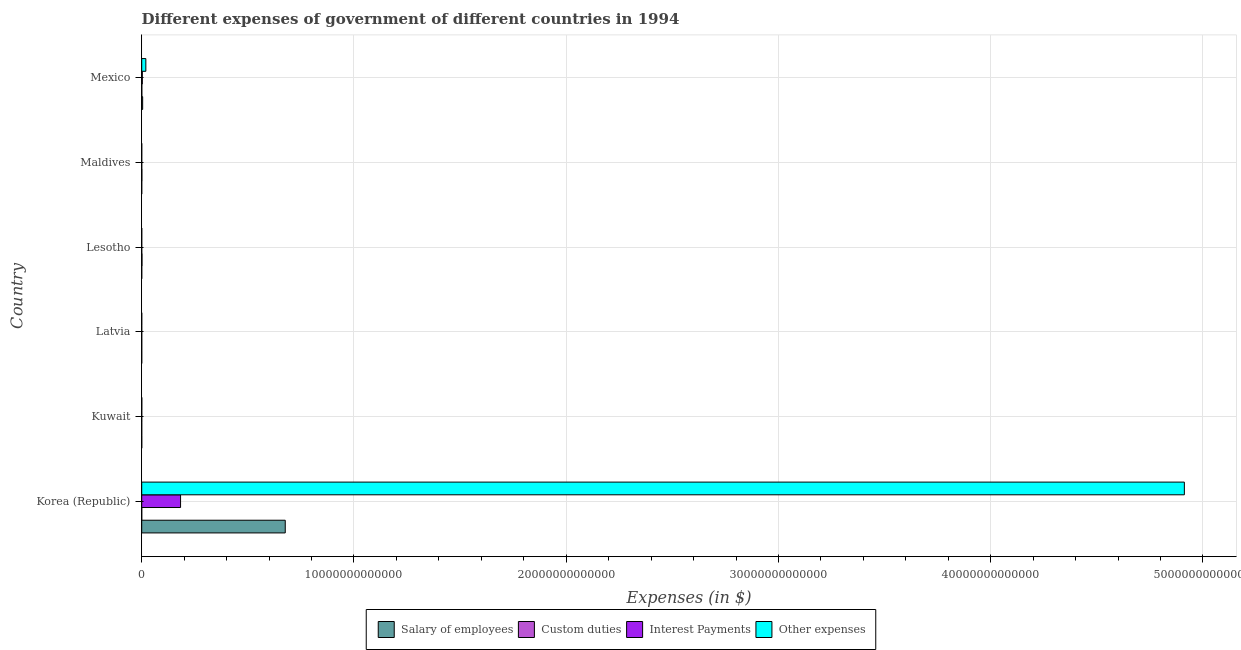How many different coloured bars are there?
Provide a short and direct response. 4. Are the number of bars per tick equal to the number of legend labels?
Provide a short and direct response. Yes. How many bars are there on the 6th tick from the bottom?
Your answer should be compact. 4. What is the label of the 3rd group of bars from the top?
Provide a succinct answer. Lesotho. In how many cases, is the number of bars for a given country not equal to the number of legend labels?
Keep it short and to the point. 0. What is the amount spent on interest payments in Mexico?
Your answer should be compact. 2.85e+1. Across all countries, what is the maximum amount spent on interest payments?
Offer a terse response. 1.83e+12. Across all countries, what is the minimum amount spent on salary of employees?
Ensure brevity in your answer.  9.94e+07. In which country was the amount spent on interest payments maximum?
Ensure brevity in your answer.  Korea (Republic). In which country was the amount spent on interest payments minimum?
Your response must be concise. Latvia. What is the total amount spent on custom duties in the graph?
Your answer should be very brief. 2.49e+1. What is the difference between the amount spent on other expenses in Korea (Republic) and that in Kuwait?
Make the answer very short. 4.91e+13. What is the difference between the amount spent on custom duties in Kuwait and the amount spent on interest payments in Korea (Republic)?
Make the answer very short. -1.83e+12. What is the average amount spent on other expenses per country?
Give a very brief answer. 8.22e+12. What is the difference between the amount spent on salary of employees and amount spent on custom duties in Latvia?
Make the answer very short. -2.41e+08. What is the ratio of the amount spent on salary of employees in Latvia to that in Mexico?
Your answer should be compact. 0. Is the amount spent on salary of employees in Korea (Republic) less than that in Lesotho?
Provide a short and direct response. No. Is the difference between the amount spent on custom duties in Kuwait and Maldives greater than the difference between the amount spent on other expenses in Kuwait and Maldives?
Your response must be concise. No. What is the difference between the highest and the second highest amount spent on other expenses?
Offer a very short reply. 4.89e+13. What is the difference between the highest and the lowest amount spent on other expenses?
Your answer should be compact. 4.91e+13. Is the sum of the amount spent on other expenses in Lesotho and Mexico greater than the maximum amount spent on interest payments across all countries?
Offer a terse response. No. Is it the case that in every country, the sum of the amount spent on other expenses and amount spent on interest payments is greater than the sum of amount spent on salary of employees and amount spent on custom duties?
Offer a terse response. No. What does the 3rd bar from the top in Maldives represents?
Keep it short and to the point. Custom duties. What does the 1st bar from the bottom in Lesotho represents?
Your response must be concise. Salary of employees. How many bars are there?
Make the answer very short. 24. Are all the bars in the graph horizontal?
Give a very brief answer. Yes. How many countries are there in the graph?
Provide a succinct answer. 6. What is the difference between two consecutive major ticks on the X-axis?
Your answer should be very brief. 1.00e+13. Does the graph contain any zero values?
Ensure brevity in your answer.  No. Where does the legend appear in the graph?
Offer a terse response. Bottom center. What is the title of the graph?
Provide a short and direct response. Different expenses of government of different countries in 1994. Does "Terrestrial protected areas" appear as one of the legend labels in the graph?
Offer a very short reply. No. What is the label or title of the X-axis?
Give a very brief answer. Expenses (in $). What is the Expenses (in $) in Salary of employees in Korea (Republic)?
Your answer should be very brief. 6.76e+12. What is the Expenses (in $) of Custom duties in Korea (Republic)?
Provide a succinct answer. 6.80e+07. What is the Expenses (in $) in Interest Payments in Korea (Republic)?
Provide a succinct answer. 1.83e+12. What is the Expenses (in $) of Other expenses in Korea (Republic)?
Ensure brevity in your answer.  4.91e+13. What is the Expenses (in $) of Salary of employees in Kuwait?
Offer a terse response. 1.11e+09. What is the Expenses (in $) of Custom duties in Kuwait?
Offer a terse response. 2.34e+07. What is the Expenses (in $) of Interest Payments in Kuwait?
Provide a succinct answer. 3.96e+08. What is the Expenses (in $) in Other expenses in Kuwait?
Offer a terse response. 3.63e+09. What is the Expenses (in $) in Salary of employees in Latvia?
Offer a terse response. 9.94e+07. What is the Expenses (in $) in Custom duties in Latvia?
Your response must be concise. 3.40e+08. What is the Expenses (in $) in Interest Payments in Latvia?
Make the answer very short. 8.72e+06. What is the Expenses (in $) of Other expenses in Latvia?
Offer a very short reply. 5.43e+08. What is the Expenses (in $) in Salary of employees in Lesotho?
Provide a succinct answer. 4.60e+08. What is the Expenses (in $) of Custom duties in Lesotho?
Provide a succinct answer. 1.27e+1. What is the Expenses (in $) of Interest Payments in Lesotho?
Keep it short and to the point. 4.94e+07. What is the Expenses (in $) in Other expenses in Lesotho?
Provide a short and direct response. 1.05e+09. What is the Expenses (in $) of Salary of employees in Maldives?
Make the answer very short. 1.85e+08. What is the Expenses (in $) of Custom duties in Maldives?
Your answer should be compact. 7.54e+09. What is the Expenses (in $) of Interest Payments in Maldives?
Offer a terse response. 5.61e+07. What is the Expenses (in $) of Other expenses in Maldives?
Provide a succinct answer. 6.92e+08. What is the Expenses (in $) of Salary of employees in Mexico?
Provide a succinct answer. 4.41e+1. What is the Expenses (in $) of Custom duties in Mexico?
Provide a succinct answer. 4.22e+09. What is the Expenses (in $) in Interest Payments in Mexico?
Make the answer very short. 2.85e+1. What is the Expenses (in $) of Other expenses in Mexico?
Your answer should be compact. 1.94e+11. Across all countries, what is the maximum Expenses (in $) of Salary of employees?
Give a very brief answer. 6.76e+12. Across all countries, what is the maximum Expenses (in $) of Custom duties?
Make the answer very short. 1.27e+1. Across all countries, what is the maximum Expenses (in $) of Interest Payments?
Offer a very short reply. 1.83e+12. Across all countries, what is the maximum Expenses (in $) in Other expenses?
Provide a short and direct response. 4.91e+13. Across all countries, what is the minimum Expenses (in $) in Salary of employees?
Give a very brief answer. 9.94e+07. Across all countries, what is the minimum Expenses (in $) of Custom duties?
Offer a very short reply. 2.34e+07. Across all countries, what is the minimum Expenses (in $) of Interest Payments?
Your response must be concise. 8.72e+06. Across all countries, what is the minimum Expenses (in $) of Other expenses?
Ensure brevity in your answer.  5.43e+08. What is the total Expenses (in $) of Salary of employees in the graph?
Ensure brevity in your answer.  6.81e+12. What is the total Expenses (in $) of Custom duties in the graph?
Your answer should be compact. 2.49e+1. What is the total Expenses (in $) in Interest Payments in the graph?
Provide a short and direct response. 1.86e+12. What is the total Expenses (in $) in Other expenses in the graph?
Provide a short and direct response. 4.93e+13. What is the difference between the Expenses (in $) in Salary of employees in Korea (Republic) and that in Kuwait?
Ensure brevity in your answer.  6.76e+12. What is the difference between the Expenses (in $) of Custom duties in Korea (Republic) and that in Kuwait?
Make the answer very short. 4.46e+07. What is the difference between the Expenses (in $) of Interest Payments in Korea (Republic) and that in Kuwait?
Your response must be concise. 1.83e+12. What is the difference between the Expenses (in $) in Other expenses in Korea (Republic) and that in Kuwait?
Provide a short and direct response. 4.91e+13. What is the difference between the Expenses (in $) of Salary of employees in Korea (Republic) and that in Latvia?
Provide a succinct answer. 6.76e+12. What is the difference between the Expenses (in $) of Custom duties in Korea (Republic) and that in Latvia?
Your answer should be very brief. -2.72e+08. What is the difference between the Expenses (in $) of Interest Payments in Korea (Republic) and that in Latvia?
Your answer should be compact. 1.83e+12. What is the difference between the Expenses (in $) of Other expenses in Korea (Republic) and that in Latvia?
Ensure brevity in your answer.  4.91e+13. What is the difference between the Expenses (in $) in Salary of employees in Korea (Republic) and that in Lesotho?
Your answer should be very brief. 6.76e+12. What is the difference between the Expenses (in $) in Custom duties in Korea (Republic) and that in Lesotho?
Give a very brief answer. -1.26e+1. What is the difference between the Expenses (in $) of Interest Payments in Korea (Republic) and that in Lesotho?
Give a very brief answer. 1.83e+12. What is the difference between the Expenses (in $) of Other expenses in Korea (Republic) and that in Lesotho?
Make the answer very short. 4.91e+13. What is the difference between the Expenses (in $) in Salary of employees in Korea (Republic) and that in Maldives?
Offer a terse response. 6.76e+12. What is the difference between the Expenses (in $) in Custom duties in Korea (Republic) and that in Maldives?
Your answer should be compact. -7.47e+09. What is the difference between the Expenses (in $) in Interest Payments in Korea (Republic) and that in Maldives?
Your answer should be compact. 1.83e+12. What is the difference between the Expenses (in $) in Other expenses in Korea (Republic) and that in Maldives?
Give a very brief answer. 4.91e+13. What is the difference between the Expenses (in $) in Salary of employees in Korea (Republic) and that in Mexico?
Your answer should be compact. 6.72e+12. What is the difference between the Expenses (in $) in Custom duties in Korea (Republic) and that in Mexico?
Your response must be concise. -4.16e+09. What is the difference between the Expenses (in $) in Interest Payments in Korea (Republic) and that in Mexico?
Give a very brief answer. 1.80e+12. What is the difference between the Expenses (in $) in Other expenses in Korea (Republic) and that in Mexico?
Your response must be concise. 4.89e+13. What is the difference between the Expenses (in $) in Salary of employees in Kuwait and that in Latvia?
Make the answer very short. 1.01e+09. What is the difference between the Expenses (in $) in Custom duties in Kuwait and that in Latvia?
Offer a terse response. -3.17e+08. What is the difference between the Expenses (in $) in Interest Payments in Kuwait and that in Latvia?
Your response must be concise. 3.87e+08. What is the difference between the Expenses (in $) in Other expenses in Kuwait and that in Latvia?
Keep it short and to the point. 3.09e+09. What is the difference between the Expenses (in $) of Salary of employees in Kuwait and that in Lesotho?
Your response must be concise. 6.48e+08. What is the difference between the Expenses (in $) of Custom duties in Kuwait and that in Lesotho?
Ensure brevity in your answer.  -1.27e+1. What is the difference between the Expenses (in $) of Interest Payments in Kuwait and that in Lesotho?
Your answer should be very brief. 3.47e+08. What is the difference between the Expenses (in $) of Other expenses in Kuwait and that in Lesotho?
Keep it short and to the point. 2.58e+09. What is the difference between the Expenses (in $) of Salary of employees in Kuwait and that in Maldives?
Ensure brevity in your answer.  9.23e+08. What is the difference between the Expenses (in $) in Custom duties in Kuwait and that in Maldives?
Keep it short and to the point. -7.52e+09. What is the difference between the Expenses (in $) of Interest Payments in Kuwait and that in Maldives?
Your response must be concise. 3.40e+08. What is the difference between the Expenses (in $) of Other expenses in Kuwait and that in Maldives?
Your answer should be compact. 2.94e+09. What is the difference between the Expenses (in $) in Salary of employees in Kuwait and that in Mexico?
Provide a succinct answer. -4.30e+1. What is the difference between the Expenses (in $) of Custom duties in Kuwait and that in Mexico?
Offer a very short reply. -4.20e+09. What is the difference between the Expenses (in $) of Interest Payments in Kuwait and that in Mexico?
Your response must be concise. -2.81e+1. What is the difference between the Expenses (in $) of Other expenses in Kuwait and that in Mexico?
Your answer should be very brief. -1.91e+11. What is the difference between the Expenses (in $) in Salary of employees in Latvia and that in Lesotho?
Ensure brevity in your answer.  -3.60e+08. What is the difference between the Expenses (in $) in Custom duties in Latvia and that in Lesotho?
Your response must be concise. -1.24e+1. What is the difference between the Expenses (in $) of Interest Payments in Latvia and that in Lesotho?
Your response must be concise. -4.07e+07. What is the difference between the Expenses (in $) of Other expenses in Latvia and that in Lesotho?
Offer a very short reply. -5.08e+08. What is the difference between the Expenses (in $) of Salary of employees in Latvia and that in Maldives?
Ensure brevity in your answer.  -8.55e+07. What is the difference between the Expenses (in $) in Custom duties in Latvia and that in Maldives?
Offer a terse response. -7.20e+09. What is the difference between the Expenses (in $) in Interest Payments in Latvia and that in Maldives?
Your answer should be very brief. -4.74e+07. What is the difference between the Expenses (in $) in Other expenses in Latvia and that in Maldives?
Offer a very short reply. -1.48e+08. What is the difference between the Expenses (in $) in Salary of employees in Latvia and that in Mexico?
Keep it short and to the point. -4.40e+1. What is the difference between the Expenses (in $) in Custom duties in Latvia and that in Mexico?
Provide a short and direct response. -3.88e+09. What is the difference between the Expenses (in $) in Interest Payments in Latvia and that in Mexico?
Make the answer very short. -2.85e+1. What is the difference between the Expenses (in $) in Other expenses in Latvia and that in Mexico?
Ensure brevity in your answer.  -1.94e+11. What is the difference between the Expenses (in $) in Salary of employees in Lesotho and that in Maldives?
Make the answer very short. 2.75e+08. What is the difference between the Expenses (in $) in Custom duties in Lesotho and that in Maldives?
Give a very brief answer. 5.17e+09. What is the difference between the Expenses (in $) of Interest Payments in Lesotho and that in Maldives?
Provide a succinct answer. -6.70e+06. What is the difference between the Expenses (in $) of Other expenses in Lesotho and that in Maldives?
Your answer should be compact. 3.59e+08. What is the difference between the Expenses (in $) in Salary of employees in Lesotho and that in Mexico?
Ensure brevity in your answer.  -4.37e+1. What is the difference between the Expenses (in $) in Custom duties in Lesotho and that in Mexico?
Offer a very short reply. 8.48e+09. What is the difference between the Expenses (in $) in Interest Payments in Lesotho and that in Mexico?
Keep it short and to the point. -2.84e+1. What is the difference between the Expenses (in $) of Other expenses in Lesotho and that in Mexico?
Your response must be concise. -1.93e+11. What is the difference between the Expenses (in $) in Salary of employees in Maldives and that in Mexico?
Give a very brief answer. -4.39e+1. What is the difference between the Expenses (in $) of Custom duties in Maldives and that in Mexico?
Your answer should be very brief. 3.32e+09. What is the difference between the Expenses (in $) in Interest Payments in Maldives and that in Mexico?
Provide a short and direct response. -2.84e+1. What is the difference between the Expenses (in $) of Other expenses in Maldives and that in Mexico?
Your response must be concise. -1.94e+11. What is the difference between the Expenses (in $) of Salary of employees in Korea (Republic) and the Expenses (in $) of Custom duties in Kuwait?
Provide a succinct answer. 6.76e+12. What is the difference between the Expenses (in $) in Salary of employees in Korea (Republic) and the Expenses (in $) in Interest Payments in Kuwait?
Offer a very short reply. 6.76e+12. What is the difference between the Expenses (in $) of Salary of employees in Korea (Republic) and the Expenses (in $) of Other expenses in Kuwait?
Ensure brevity in your answer.  6.76e+12. What is the difference between the Expenses (in $) of Custom duties in Korea (Republic) and the Expenses (in $) of Interest Payments in Kuwait?
Your response must be concise. -3.28e+08. What is the difference between the Expenses (in $) of Custom duties in Korea (Republic) and the Expenses (in $) of Other expenses in Kuwait?
Provide a succinct answer. -3.57e+09. What is the difference between the Expenses (in $) in Interest Payments in Korea (Republic) and the Expenses (in $) in Other expenses in Kuwait?
Keep it short and to the point. 1.83e+12. What is the difference between the Expenses (in $) in Salary of employees in Korea (Republic) and the Expenses (in $) in Custom duties in Latvia?
Give a very brief answer. 6.76e+12. What is the difference between the Expenses (in $) of Salary of employees in Korea (Republic) and the Expenses (in $) of Interest Payments in Latvia?
Give a very brief answer. 6.76e+12. What is the difference between the Expenses (in $) of Salary of employees in Korea (Republic) and the Expenses (in $) of Other expenses in Latvia?
Provide a succinct answer. 6.76e+12. What is the difference between the Expenses (in $) of Custom duties in Korea (Republic) and the Expenses (in $) of Interest Payments in Latvia?
Offer a very short reply. 5.93e+07. What is the difference between the Expenses (in $) of Custom duties in Korea (Republic) and the Expenses (in $) of Other expenses in Latvia?
Keep it short and to the point. -4.75e+08. What is the difference between the Expenses (in $) in Interest Payments in Korea (Republic) and the Expenses (in $) in Other expenses in Latvia?
Your answer should be compact. 1.83e+12. What is the difference between the Expenses (in $) in Salary of employees in Korea (Republic) and the Expenses (in $) in Custom duties in Lesotho?
Provide a succinct answer. 6.75e+12. What is the difference between the Expenses (in $) of Salary of employees in Korea (Republic) and the Expenses (in $) of Interest Payments in Lesotho?
Offer a terse response. 6.76e+12. What is the difference between the Expenses (in $) in Salary of employees in Korea (Republic) and the Expenses (in $) in Other expenses in Lesotho?
Give a very brief answer. 6.76e+12. What is the difference between the Expenses (in $) in Custom duties in Korea (Republic) and the Expenses (in $) in Interest Payments in Lesotho?
Make the answer very short. 1.86e+07. What is the difference between the Expenses (in $) of Custom duties in Korea (Republic) and the Expenses (in $) of Other expenses in Lesotho?
Provide a succinct answer. -9.83e+08. What is the difference between the Expenses (in $) in Interest Payments in Korea (Republic) and the Expenses (in $) in Other expenses in Lesotho?
Ensure brevity in your answer.  1.83e+12. What is the difference between the Expenses (in $) of Salary of employees in Korea (Republic) and the Expenses (in $) of Custom duties in Maldives?
Provide a short and direct response. 6.75e+12. What is the difference between the Expenses (in $) of Salary of employees in Korea (Republic) and the Expenses (in $) of Interest Payments in Maldives?
Provide a succinct answer. 6.76e+12. What is the difference between the Expenses (in $) in Salary of employees in Korea (Republic) and the Expenses (in $) in Other expenses in Maldives?
Make the answer very short. 6.76e+12. What is the difference between the Expenses (in $) of Custom duties in Korea (Republic) and the Expenses (in $) of Interest Payments in Maldives?
Give a very brief answer. 1.19e+07. What is the difference between the Expenses (in $) in Custom duties in Korea (Republic) and the Expenses (in $) in Other expenses in Maldives?
Give a very brief answer. -6.24e+08. What is the difference between the Expenses (in $) of Interest Payments in Korea (Republic) and the Expenses (in $) of Other expenses in Maldives?
Offer a very short reply. 1.83e+12. What is the difference between the Expenses (in $) of Salary of employees in Korea (Republic) and the Expenses (in $) of Custom duties in Mexico?
Make the answer very short. 6.76e+12. What is the difference between the Expenses (in $) of Salary of employees in Korea (Republic) and the Expenses (in $) of Interest Payments in Mexico?
Offer a very short reply. 6.73e+12. What is the difference between the Expenses (in $) of Salary of employees in Korea (Republic) and the Expenses (in $) of Other expenses in Mexico?
Offer a very short reply. 6.57e+12. What is the difference between the Expenses (in $) in Custom duties in Korea (Republic) and the Expenses (in $) in Interest Payments in Mexico?
Give a very brief answer. -2.84e+1. What is the difference between the Expenses (in $) of Custom duties in Korea (Republic) and the Expenses (in $) of Other expenses in Mexico?
Offer a terse response. -1.94e+11. What is the difference between the Expenses (in $) in Interest Payments in Korea (Republic) and the Expenses (in $) in Other expenses in Mexico?
Provide a short and direct response. 1.64e+12. What is the difference between the Expenses (in $) in Salary of employees in Kuwait and the Expenses (in $) in Custom duties in Latvia?
Ensure brevity in your answer.  7.68e+08. What is the difference between the Expenses (in $) of Salary of employees in Kuwait and the Expenses (in $) of Interest Payments in Latvia?
Give a very brief answer. 1.10e+09. What is the difference between the Expenses (in $) in Salary of employees in Kuwait and the Expenses (in $) in Other expenses in Latvia?
Your response must be concise. 5.65e+08. What is the difference between the Expenses (in $) in Custom duties in Kuwait and the Expenses (in $) in Interest Payments in Latvia?
Provide a short and direct response. 1.47e+07. What is the difference between the Expenses (in $) in Custom duties in Kuwait and the Expenses (in $) in Other expenses in Latvia?
Ensure brevity in your answer.  -5.20e+08. What is the difference between the Expenses (in $) in Interest Payments in Kuwait and the Expenses (in $) in Other expenses in Latvia?
Offer a terse response. -1.47e+08. What is the difference between the Expenses (in $) of Salary of employees in Kuwait and the Expenses (in $) of Custom duties in Lesotho?
Your answer should be very brief. -1.16e+1. What is the difference between the Expenses (in $) in Salary of employees in Kuwait and the Expenses (in $) in Interest Payments in Lesotho?
Your answer should be compact. 1.06e+09. What is the difference between the Expenses (in $) in Salary of employees in Kuwait and the Expenses (in $) in Other expenses in Lesotho?
Give a very brief answer. 5.67e+07. What is the difference between the Expenses (in $) of Custom duties in Kuwait and the Expenses (in $) of Interest Payments in Lesotho?
Ensure brevity in your answer.  -2.60e+07. What is the difference between the Expenses (in $) in Custom duties in Kuwait and the Expenses (in $) in Other expenses in Lesotho?
Provide a succinct answer. -1.03e+09. What is the difference between the Expenses (in $) of Interest Payments in Kuwait and the Expenses (in $) of Other expenses in Lesotho?
Give a very brief answer. -6.55e+08. What is the difference between the Expenses (in $) in Salary of employees in Kuwait and the Expenses (in $) in Custom duties in Maldives?
Your answer should be very brief. -6.43e+09. What is the difference between the Expenses (in $) of Salary of employees in Kuwait and the Expenses (in $) of Interest Payments in Maldives?
Ensure brevity in your answer.  1.05e+09. What is the difference between the Expenses (in $) in Salary of employees in Kuwait and the Expenses (in $) in Other expenses in Maldives?
Ensure brevity in your answer.  4.16e+08. What is the difference between the Expenses (in $) in Custom duties in Kuwait and the Expenses (in $) in Interest Payments in Maldives?
Your answer should be compact. -3.27e+07. What is the difference between the Expenses (in $) in Custom duties in Kuwait and the Expenses (in $) in Other expenses in Maldives?
Offer a very short reply. -6.68e+08. What is the difference between the Expenses (in $) of Interest Payments in Kuwait and the Expenses (in $) of Other expenses in Maldives?
Your answer should be compact. -2.96e+08. What is the difference between the Expenses (in $) in Salary of employees in Kuwait and the Expenses (in $) in Custom duties in Mexico?
Your answer should be very brief. -3.12e+09. What is the difference between the Expenses (in $) in Salary of employees in Kuwait and the Expenses (in $) in Interest Payments in Mexico?
Make the answer very short. -2.74e+1. What is the difference between the Expenses (in $) in Salary of employees in Kuwait and the Expenses (in $) in Other expenses in Mexico?
Provide a succinct answer. -1.93e+11. What is the difference between the Expenses (in $) of Custom duties in Kuwait and the Expenses (in $) of Interest Payments in Mexico?
Ensure brevity in your answer.  -2.85e+1. What is the difference between the Expenses (in $) in Custom duties in Kuwait and the Expenses (in $) in Other expenses in Mexico?
Ensure brevity in your answer.  -1.94e+11. What is the difference between the Expenses (in $) of Interest Payments in Kuwait and the Expenses (in $) of Other expenses in Mexico?
Provide a short and direct response. -1.94e+11. What is the difference between the Expenses (in $) in Salary of employees in Latvia and the Expenses (in $) in Custom duties in Lesotho?
Make the answer very short. -1.26e+1. What is the difference between the Expenses (in $) of Salary of employees in Latvia and the Expenses (in $) of Interest Payments in Lesotho?
Make the answer very short. 5.00e+07. What is the difference between the Expenses (in $) of Salary of employees in Latvia and the Expenses (in $) of Other expenses in Lesotho?
Offer a terse response. -9.52e+08. What is the difference between the Expenses (in $) in Custom duties in Latvia and the Expenses (in $) in Interest Payments in Lesotho?
Your response must be concise. 2.91e+08. What is the difference between the Expenses (in $) of Custom duties in Latvia and the Expenses (in $) of Other expenses in Lesotho?
Keep it short and to the point. -7.11e+08. What is the difference between the Expenses (in $) in Interest Payments in Latvia and the Expenses (in $) in Other expenses in Lesotho?
Ensure brevity in your answer.  -1.04e+09. What is the difference between the Expenses (in $) in Salary of employees in Latvia and the Expenses (in $) in Custom duties in Maldives?
Your answer should be very brief. -7.44e+09. What is the difference between the Expenses (in $) of Salary of employees in Latvia and the Expenses (in $) of Interest Payments in Maldives?
Offer a terse response. 4.33e+07. What is the difference between the Expenses (in $) in Salary of employees in Latvia and the Expenses (in $) in Other expenses in Maldives?
Your response must be concise. -5.92e+08. What is the difference between the Expenses (in $) in Custom duties in Latvia and the Expenses (in $) in Interest Payments in Maldives?
Give a very brief answer. 2.84e+08. What is the difference between the Expenses (in $) in Custom duties in Latvia and the Expenses (in $) in Other expenses in Maldives?
Your answer should be very brief. -3.52e+08. What is the difference between the Expenses (in $) of Interest Payments in Latvia and the Expenses (in $) of Other expenses in Maldives?
Your response must be concise. -6.83e+08. What is the difference between the Expenses (in $) of Salary of employees in Latvia and the Expenses (in $) of Custom duties in Mexico?
Provide a succinct answer. -4.13e+09. What is the difference between the Expenses (in $) in Salary of employees in Latvia and the Expenses (in $) in Interest Payments in Mexico?
Provide a short and direct response. -2.84e+1. What is the difference between the Expenses (in $) of Salary of employees in Latvia and the Expenses (in $) of Other expenses in Mexico?
Keep it short and to the point. -1.94e+11. What is the difference between the Expenses (in $) in Custom duties in Latvia and the Expenses (in $) in Interest Payments in Mexico?
Make the answer very short. -2.81e+1. What is the difference between the Expenses (in $) of Custom duties in Latvia and the Expenses (in $) of Other expenses in Mexico?
Make the answer very short. -1.94e+11. What is the difference between the Expenses (in $) in Interest Payments in Latvia and the Expenses (in $) in Other expenses in Mexico?
Offer a terse response. -1.94e+11. What is the difference between the Expenses (in $) in Salary of employees in Lesotho and the Expenses (in $) in Custom duties in Maldives?
Give a very brief answer. -7.08e+09. What is the difference between the Expenses (in $) in Salary of employees in Lesotho and the Expenses (in $) in Interest Payments in Maldives?
Your answer should be compact. 4.04e+08. What is the difference between the Expenses (in $) of Salary of employees in Lesotho and the Expenses (in $) of Other expenses in Maldives?
Your answer should be very brief. -2.32e+08. What is the difference between the Expenses (in $) in Custom duties in Lesotho and the Expenses (in $) in Interest Payments in Maldives?
Provide a short and direct response. 1.27e+1. What is the difference between the Expenses (in $) in Custom duties in Lesotho and the Expenses (in $) in Other expenses in Maldives?
Provide a succinct answer. 1.20e+1. What is the difference between the Expenses (in $) in Interest Payments in Lesotho and the Expenses (in $) in Other expenses in Maldives?
Your response must be concise. -6.42e+08. What is the difference between the Expenses (in $) in Salary of employees in Lesotho and the Expenses (in $) in Custom duties in Mexico?
Offer a terse response. -3.77e+09. What is the difference between the Expenses (in $) of Salary of employees in Lesotho and the Expenses (in $) of Interest Payments in Mexico?
Ensure brevity in your answer.  -2.80e+1. What is the difference between the Expenses (in $) of Salary of employees in Lesotho and the Expenses (in $) of Other expenses in Mexico?
Your response must be concise. -1.94e+11. What is the difference between the Expenses (in $) of Custom duties in Lesotho and the Expenses (in $) of Interest Payments in Mexico?
Keep it short and to the point. -1.58e+1. What is the difference between the Expenses (in $) in Custom duties in Lesotho and the Expenses (in $) in Other expenses in Mexico?
Your answer should be compact. -1.82e+11. What is the difference between the Expenses (in $) of Interest Payments in Lesotho and the Expenses (in $) of Other expenses in Mexico?
Your response must be concise. -1.94e+11. What is the difference between the Expenses (in $) in Salary of employees in Maldives and the Expenses (in $) in Custom duties in Mexico?
Your response must be concise. -4.04e+09. What is the difference between the Expenses (in $) in Salary of employees in Maldives and the Expenses (in $) in Interest Payments in Mexico?
Your answer should be very brief. -2.83e+1. What is the difference between the Expenses (in $) in Salary of employees in Maldives and the Expenses (in $) in Other expenses in Mexico?
Ensure brevity in your answer.  -1.94e+11. What is the difference between the Expenses (in $) of Custom duties in Maldives and the Expenses (in $) of Interest Payments in Mexico?
Offer a terse response. -2.09e+1. What is the difference between the Expenses (in $) of Custom duties in Maldives and the Expenses (in $) of Other expenses in Mexico?
Your answer should be compact. -1.87e+11. What is the difference between the Expenses (in $) of Interest Payments in Maldives and the Expenses (in $) of Other expenses in Mexico?
Provide a short and direct response. -1.94e+11. What is the average Expenses (in $) of Salary of employees per country?
Make the answer very short. 1.13e+12. What is the average Expenses (in $) of Custom duties per country?
Give a very brief answer. 4.15e+09. What is the average Expenses (in $) in Interest Payments per country?
Make the answer very short. 3.10e+11. What is the average Expenses (in $) in Other expenses per country?
Offer a very short reply. 8.22e+12. What is the difference between the Expenses (in $) in Salary of employees and Expenses (in $) in Custom duties in Korea (Republic)?
Make the answer very short. 6.76e+12. What is the difference between the Expenses (in $) in Salary of employees and Expenses (in $) in Interest Payments in Korea (Republic)?
Keep it short and to the point. 4.93e+12. What is the difference between the Expenses (in $) in Salary of employees and Expenses (in $) in Other expenses in Korea (Republic)?
Provide a succinct answer. -4.24e+13. What is the difference between the Expenses (in $) of Custom duties and Expenses (in $) of Interest Payments in Korea (Republic)?
Give a very brief answer. -1.83e+12. What is the difference between the Expenses (in $) in Custom duties and Expenses (in $) in Other expenses in Korea (Republic)?
Your response must be concise. -4.91e+13. What is the difference between the Expenses (in $) of Interest Payments and Expenses (in $) of Other expenses in Korea (Republic)?
Provide a succinct answer. -4.73e+13. What is the difference between the Expenses (in $) of Salary of employees and Expenses (in $) of Custom duties in Kuwait?
Make the answer very short. 1.08e+09. What is the difference between the Expenses (in $) of Salary of employees and Expenses (in $) of Interest Payments in Kuwait?
Ensure brevity in your answer.  7.12e+08. What is the difference between the Expenses (in $) in Salary of employees and Expenses (in $) in Other expenses in Kuwait?
Provide a succinct answer. -2.53e+09. What is the difference between the Expenses (in $) in Custom duties and Expenses (in $) in Interest Payments in Kuwait?
Provide a succinct answer. -3.73e+08. What is the difference between the Expenses (in $) of Custom duties and Expenses (in $) of Other expenses in Kuwait?
Your answer should be very brief. -3.61e+09. What is the difference between the Expenses (in $) in Interest Payments and Expenses (in $) in Other expenses in Kuwait?
Offer a terse response. -3.24e+09. What is the difference between the Expenses (in $) in Salary of employees and Expenses (in $) in Custom duties in Latvia?
Keep it short and to the point. -2.41e+08. What is the difference between the Expenses (in $) in Salary of employees and Expenses (in $) in Interest Payments in Latvia?
Offer a very short reply. 9.07e+07. What is the difference between the Expenses (in $) in Salary of employees and Expenses (in $) in Other expenses in Latvia?
Ensure brevity in your answer.  -4.44e+08. What is the difference between the Expenses (in $) in Custom duties and Expenses (in $) in Interest Payments in Latvia?
Your answer should be very brief. 3.31e+08. What is the difference between the Expenses (in $) in Custom duties and Expenses (in $) in Other expenses in Latvia?
Ensure brevity in your answer.  -2.03e+08. What is the difference between the Expenses (in $) of Interest Payments and Expenses (in $) of Other expenses in Latvia?
Your answer should be compact. -5.35e+08. What is the difference between the Expenses (in $) in Salary of employees and Expenses (in $) in Custom duties in Lesotho?
Keep it short and to the point. -1.22e+1. What is the difference between the Expenses (in $) in Salary of employees and Expenses (in $) in Interest Payments in Lesotho?
Give a very brief answer. 4.10e+08. What is the difference between the Expenses (in $) of Salary of employees and Expenses (in $) of Other expenses in Lesotho?
Provide a short and direct response. -5.92e+08. What is the difference between the Expenses (in $) of Custom duties and Expenses (in $) of Interest Payments in Lesotho?
Ensure brevity in your answer.  1.27e+1. What is the difference between the Expenses (in $) of Custom duties and Expenses (in $) of Other expenses in Lesotho?
Your answer should be compact. 1.17e+1. What is the difference between the Expenses (in $) of Interest Payments and Expenses (in $) of Other expenses in Lesotho?
Offer a terse response. -1.00e+09. What is the difference between the Expenses (in $) in Salary of employees and Expenses (in $) in Custom duties in Maldives?
Offer a very short reply. -7.36e+09. What is the difference between the Expenses (in $) of Salary of employees and Expenses (in $) of Interest Payments in Maldives?
Provide a short and direct response. 1.29e+08. What is the difference between the Expenses (in $) in Salary of employees and Expenses (in $) in Other expenses in Maldives?
Ensure brevity in your answer.  -5.07e+08. What is the difference between the Expenses (in $) of Custom duties and Expenses (in $) of Interest Payments in Maldives?
Provide a succinct answer. 7.48e+09. What is the difference between the Expenses (in $) of Custom duties and Expenses (in $) of Other expenses in Maldives?
Give a very brief answer. 6.85e+09. What is the difference between the Expenses (in $) in Interest Payments and Expenses (in $) in Other expenses in Maldives?
Keep it short and to the point. -6.36e+08. What is the difference between the Expenses (in $) of Salary of employees and Expenses (in $) of Custom duties in Mexico?
Your answer should be very brief. 3.99e+1. What is the difference between the Expenses (in $) in Salary of employees and Expenses (in $) in Interest Payments in Mexico?
Give a very brief answer. 1.56e+1. What is the difference between the Expenses (in $) of Salary of employees and Expenses (in $) of Other expenses in Mexico?
Keep it short and to the point. -1.50e+11. What is the difference between the Expenses (in $) of Custom duties and Expenses (in $) of Interest Payments in Mexico?
Give a very brief answer. -2.43e+1. What is the difference between the Expenses (in $) of Custom duties and Expenses (in $) of Other expenses in Mexico?
Provide a short and direct response. -1.90e+11. What is the difference between the Expenses (in $) in Interest Payments and Expenses (in $) in Other expenses in Mexico?
Give a very brief answer. -1.66e+11. What is the ratio of the Expenses (in $) of Salary of employees in Korea (Republic) to that in Kuwait?
Your answer should be compact. 6102.89. What is the ratio of the Expenses (in $) in Custom duties in Korea (Republic) to that in Kuwait?
Provide a succinct answer. 2.9. What is the ratio of the Expenses (in $) in Interest Payments in Korea (Republic) to that in Kuwait?
Your answer should be very brief. 4621.21. What is the ratio of the Expenses (in $) in Other expenses in Korea (Republic) to that in Kuwait?
Provide a short and direct response. 1.35e+04. What is the ratio of the Expenses (in $) in Salary of employees in Korea (Republic) to that in Latvia?
Provide a succinct answer. 6.80e+04. What is the ratio of the Expenses (in $) in Custom duties in Korea (Republic) to that in Latvia?
Offer a terse response. 0.2. What is the ratio of the Expenses (in $) of Interest Payments in Korea (Republic) to that in Latvia?
Ensure brevity in your answer.  2.10e+05. What is the ratio of the Expenses (in $) of Other expenses in Korea (Republic) to that in Latvia?
Give a very brief answer. 9.04e+04. What is the ratio of the Expenses (in $) of Salary of employees in Korea (Republic) to that in Lesotho?
Your response must be concise. 1.47e+04. What is the ratio of the Expenses (in $) in Custom duties in Korea (Republic) to that in Lesotho?
Provide a short and direct response. 0.01. What is the ratio of the Expenses (in $) of Interest Payments in Korea (Republic) to that in Lesotho?
Offer a very short reply. 3.70e+04. What is the ratio of the Expenses (in $) of Other expenses in Korea (Republic) to that in Lesotho?
Your response must be concise. 4.67e+04. What is the ratio of the Expenses (in $) of Salary of employees in Korea (Republic) to that in Maldives?
Make the answer very short. 3.66e+04. What is the ratio of the Expenses (in $) of Custom duties in Korea (Republic) to that in Maldives?
Provide a succinct answer. 0.01. What is the ratio of the Expenses (in $) of Interest Payments in Korea (Republic) to that in Maldives?
Keep it short and to the point. 3.26e+04. What is the ratio of the Expenses (in $) in Other expenses in Korea (Republic) to that in Maldives?
Give a very brief answer. 7.10e+04. What is the ratio of the Expenses (in $) of Salary of employees in Korea (Republic) to that in Mexico?
Keep it short and to the point. 153.26. What is the ratio of the Expenses (in $) in Custom duties in Korea (Republic) to that in Mexico?
Give a very brief answer. 0.02. What is the ratio of the Expenses (in $) of Interest Payments in Korea (Republic) to that in Mexico?
Offer a very short reply. 64.23. What is the ratio of the Expenses (in $) in Other expenses in Korea (Republic) to that in Mexico?
Give a very brief answer. 252.67. What is the ratio of the Expenses (in $) in Salary of employees in Kuwait to that in Latvia?
Offer a very short reply. 11.14. What is the ratio of the Expenses (in $) in Custom duties in Kuwait to that in Latvia?
Your response must be concise. 0.07. What is the ratio of the Expenses (in $) in Interest Payments in Kuwait to that in Latvia?
Ensure brevity in your answer.  45.41. What is the ratio of the Expenses (in $) in Other expenses in Kuwait to that in Latvia?
Offer a very short reply. 6.69. What is the ratio of the Expenses (in $) in Salary of employees in Kuwait to that in Lesotho?
Ensure brevity in your answer.  2.41. What is the ratio of the Expenses (in $) of Custom duties in Kuwait to that in Lesotho?
Offer a terse response. 0. What is the ratio of the Expenses (in $) of Interest Payments in Kuwait to that in Lesotho?
Provide a short and direct response. 8.02. What is the ratio of the Expenses (in $) in Other expenses in Kuwait to that in Lesotho?
Provide a succinct answer. 3.46. What is the ratio of the Expenses (in $) in Salary of employees in Kuwait to that in Maldives?
Offer a terse response. 5.99. What is the ratio of the Expenses (in $) of Custom duties in Kuwait to that in Maldives?
Ensure brevity in your answer.  0. What is the ratio of the Expenses (in $) of Interest Payments in Kuwait to that in Maldives?
Your response must be concise. 7.06. What is the ratio of the Expenses (in $) in Other expenses in Kuwait to that in Maldives?
Provide a succinct answer. 5.25. What is the ratio of the Expenses (in $) in Salary of employees in Kuwait to that in Mexico?
Keep it short and to the point. 0.03. What is the ratio of the Expenses (in $) in Custom duties in Kuwait to that in Mexico?
Ensure brevity in your answer.  0.01. What is the ratio of the Expenses (in $) in Interest Payments in Kuwait to that in Mexico?
Provide a short and direct response. 0.01. What is the ratio of the Expenses (in $) of Other expenses in Kuwait to that in Mexico?
Your answer should be very brief. 0.02. What is the ratio of the Expenses (in $) of Salary of employees in Latvia to that in Lesotho?
Provide a short and direct response. 0.22. What is the ratio of the Expenses (in $) in Custom duties in Latvia to that in Lesotho?
Provide a succinct answer. 0.03. What is the ratio of the Expenses (in $) of Interest Payments in Latvia to that in Lesotho?
Give a very brief answer. 0.18. What is the ratio of the Expenses (in $) of Other expenses in Latvia to that in Lesotho?
Keep it short and to the point. 0.52. What is the ratio of the Expenses (in $) in Salary of employees in Latvia to that in Maldives?
Keep it short and to the point. 0.54. What is the ratio of the Expenses (in $) of Custom duties in Latvia to that in Maldives?
Offer a terse response. 0.05. What is the ratio of the Expenses (in $) in Interest Payments in Latvia to that in Maldives?
Provide a succinct answer. 0.16. What is the ratio of the Expenses (in $) of Other expenses in Latvia to that in Maldives?
Ensure brevity in your answer.  0.79. What is the ratio of the Expenses (in $) in Salary of employees in Latvia to that in Mexico?
Offer a terse response. 0. What is the ratio of the Expenses (in $) of Custom duties in Latvia to that in Mexico?
Keep it short and to the point. 0.08. What is the ratio of the Expenses (in $) in Interest Payments in Latvia to that in Mexico?
Provide a succinct answer. 0. What is the ratio of the Expenses (in $) in Other expenses in Latvia to that in Mexico?
Provide a succinct answer. 0. What is the ratio of the Expenses (in $) in Salary of employees in Lesotho to that in Maldives?
Provide a succinct answer. 2.49. What is the ratio of the Expenses (in $) in Custom duties in Lesotho to that in Maldives?
Ensure brevity in your answer.  1.69. What is the ratio of the Expenses (in $) in Interest Payments in Lesotho to that in Maldives?
Ensure brevity in your answer.  0.88. What is the ratio of the Expenses (in $) in Other expenses in Lesotho to that in Maldives?
Your answer should be compact. 1.52. What is the ratio of the Expenses (in $) in Salary of employees in Lesotho to that in Mexico?
Your response must be concise. 0.01. What is the ratio of the Expenses (in $) of Custom duties in Lesotho to that in Mexico?
Ensure brevity in your answer.  3.01. What is the ratio of the Expenses (in $) in Interest Payments in Lesotho to that in Mexico?
Provide a short and direct response. 0. What is the ratio of the Expenses (in $) of Other expenses in Lesotho to that in Mexico?
Your answer should be compact. 0.01. What is the ratio of the Expenses (in $) in Salary of employees in Maldives to that in Mexico?
Give a very brief answer. 0. What is the ratio of the Expenses (in $) in Custom duties in Maldives to that in Mexico?
Ensure brevity in your answer.  1.78. What is the ratio of the Expenses (in $) of Interest Payments in Maldives to that in Mexico?
Ensure brevity in your answer.  0. What is the ratio of the Expenses (in $) in Other expenses in Maldives to that in Mexico?
Your answer should be very brief. 0. What is the difference between the highest and the second highest Expenses (in $) in Salary of employees?
Provide a succinct answer. 6.72e+12. What is the difference between the highest and the second highest Expenses (in $) of Custom duties?
Offer a terse response. 5.17e+09. What is the difference between the highest and the second highest Expenses (in $) of Interest Payments?
Your response must be concise. 1.80e+12. What is the difference between the highest and the second highest Expenses (in $) of Other expenses?
Provide a succinct answer. 4.89e+13. What is the difference between the highest and the lowest Expenses (in $) of Salary of employees?
Provide a short and direct response. 6.76e+12. What is the difference between the highest and the lowest Expenses (in $) in Custom duties?
Your answer should be very brief. 1.27e+1. What is the difference between the highest and the lowest Expenses (in $) in Interest Payments?
Your answer should be very brief. 1.83e+12. What is the difference between the highest and the lowest Expenses (in $) in Other expenses?
Offer a very short reply. 4.91e+13. 